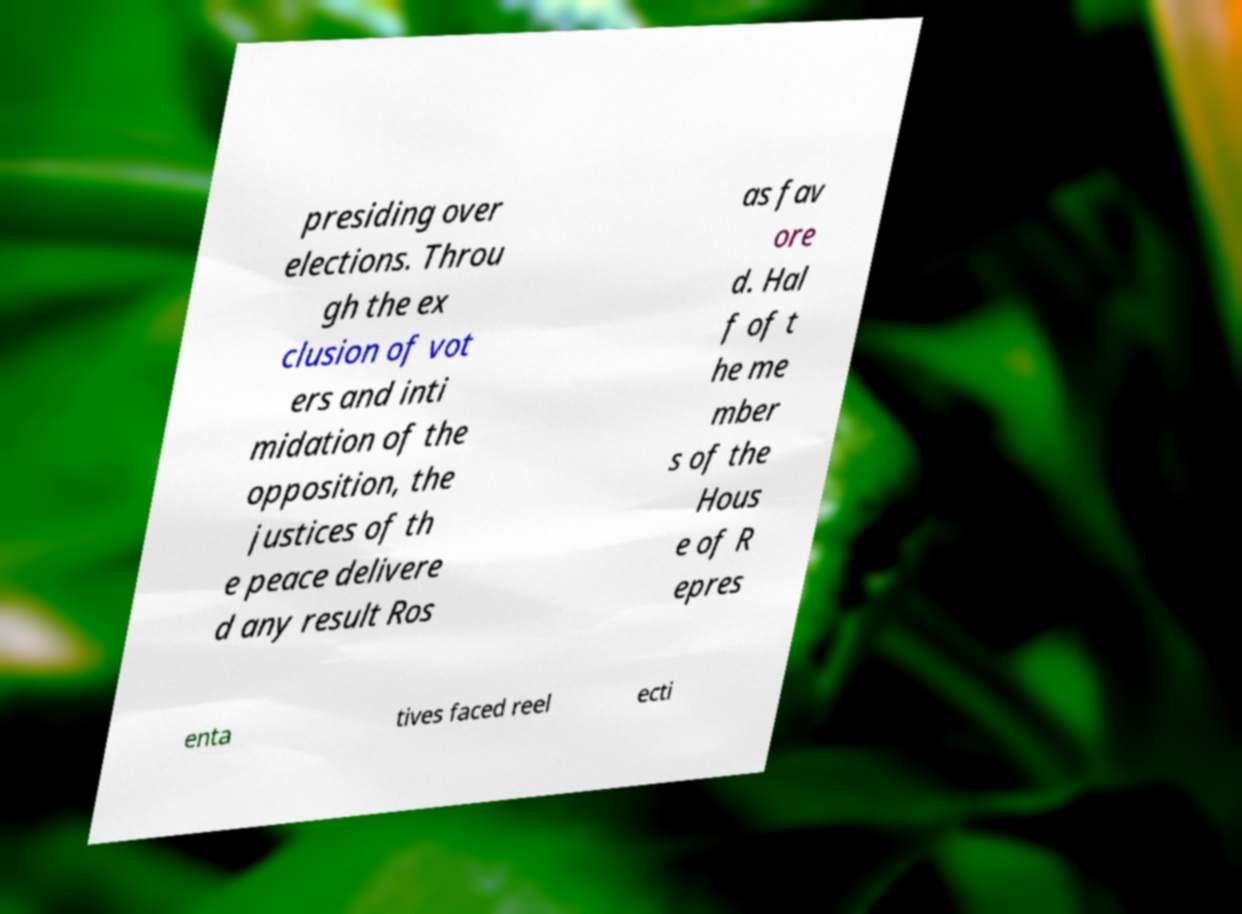Please read and relay the text visible in this image. What does it say? presiding over elections. Throu gh the ex clusion of vot ers and inti midation of the opposition, the justices of th e peace delivere d any result Ros as fav ore d. Hal f of t he me mber s of the Hous e of R epres enta tives faced reel ecti 